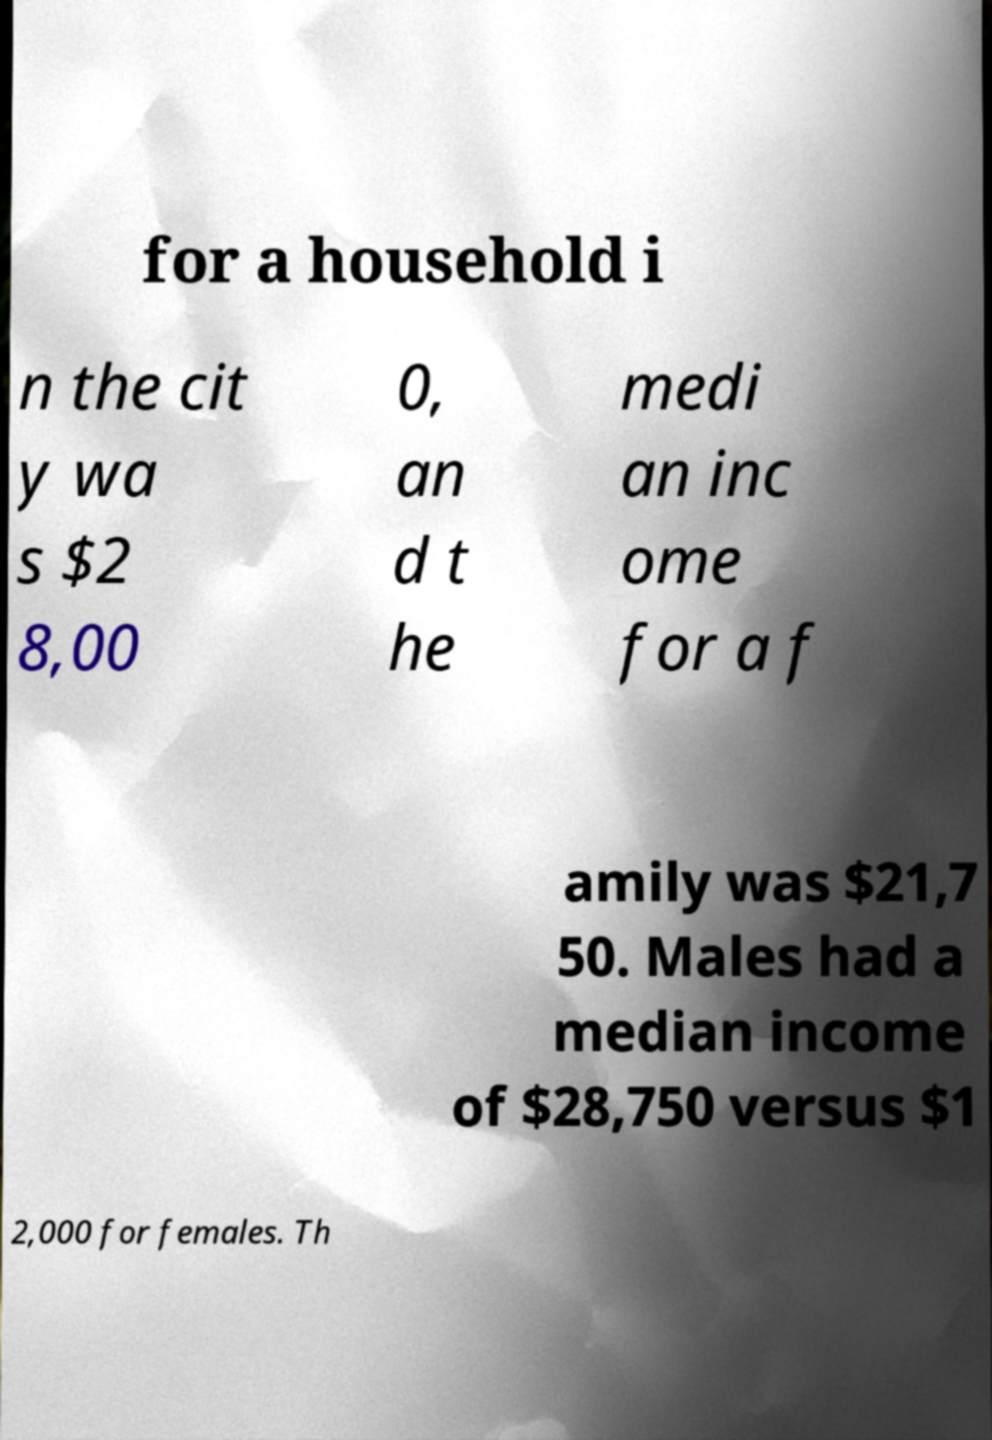There's text embedded in this image that I need extracted. Can you transcribe it verbatim? for a household i n the cit y wa s $2 8,00 0, an d t he medi an inc ome for a f amily was $21,7 50. Males had a median income of $28,750 versus $1 2,000 for females. Th 